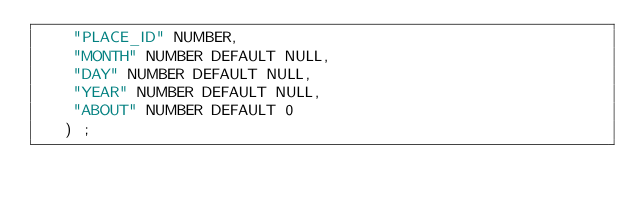Convert code to text. <code><loc_0><loc_0><loc_500><loc_500><_SQL_>	"PLACE_ID" NUMBER, 
	"MONTH" NUMBER DEFAULT NULL, 
	"DAY" NUMBER DEFAULT NULL, 
	"YEAR" NUMBER DEFAULT NULL, 
	"ABOUT" NUMBER DEFAULT 0
   ) ;
</code> 